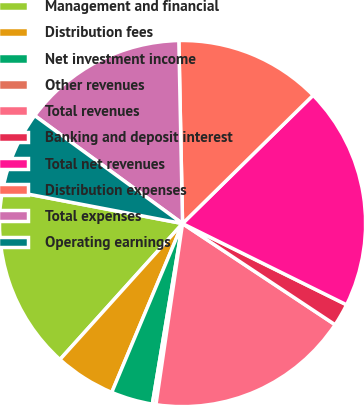Convert chart. <chart><loc_0><loc_0><loc_500><loc_500><pie_chart><fcel>Management and financial<fcel>Distribution fees<fcel>Net investment income<fcel>Other revenues<fcel>Total revenues<fcel>Banking and deposit interest<fcel>Total net revenues<fcel>Distribution expenses<fcel>Total expenses<fcel>Operating earnings<nl><fcel>16.32%<fcel>5.36%<fcel>3.68%<fcel>0.32%<fcel>18.0%<fcel>2.0%<fcel>19.68%<fcel>12.96%<fcel>14.64%<fcel>7.04%<nl></chart> 